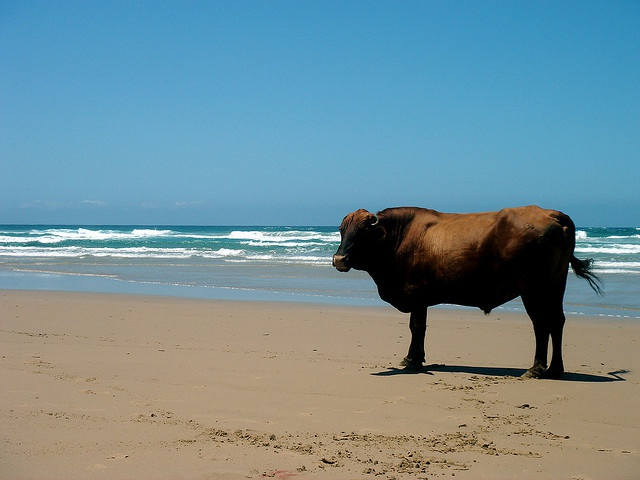Describe the objects in this image and their specific colors. I can see a cow in gray, black, brown, and maroon tones in this image. 